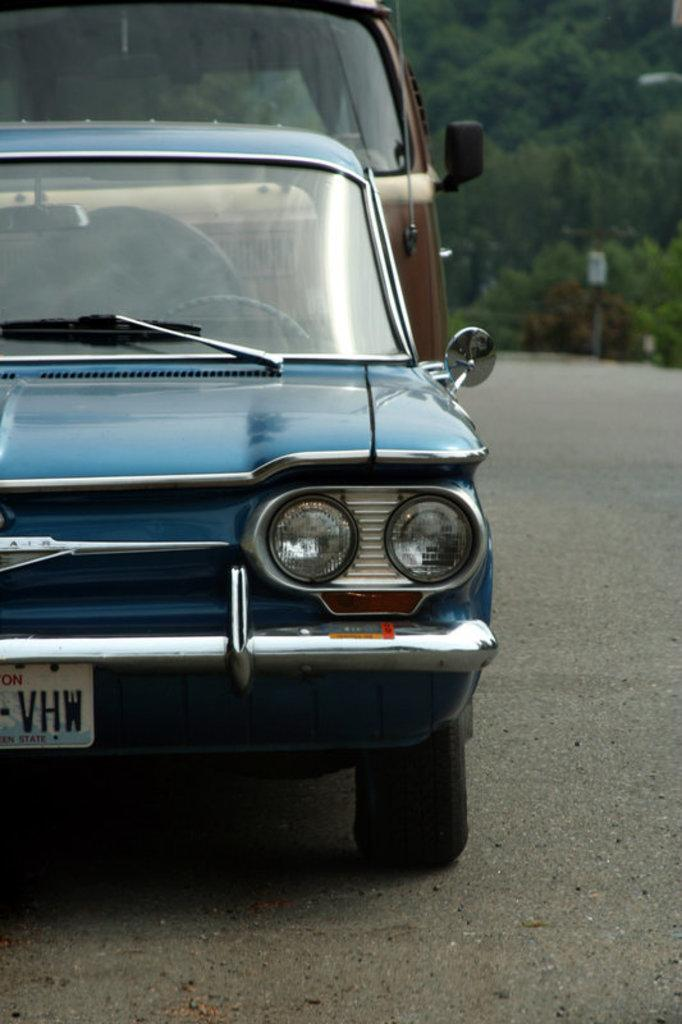What is the main feature of the image? There is a road in the image. What is happening on the road? There are vehicles on the road. What can be seen in the distance in the image? There are trees visible in the background of the image. Where is the zebra crossing the road in the image? There is no zebra present in the image, so it cannot be crossing the road. 